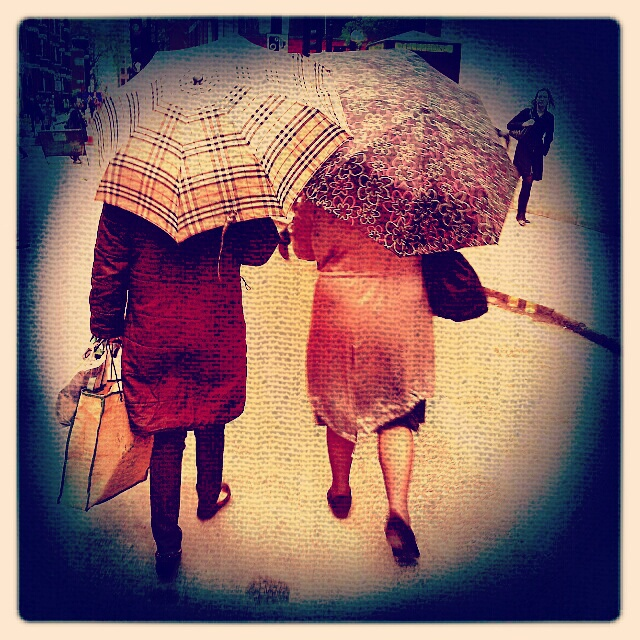Describe the objects in this image and their specific colors. I can see umbrella in beige, tan, and gray tones, people in beige, navy, purple, and brown tones, people in beige, salmon, and brown tones, umbrella in beige, brown, salmon, gray, and navy tones, and handbag in beige, salmon, brown, and gray tones in this image. 